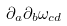Convert formula to latex. <formula><loc_0><loc_0><loc_500><loc_500>\partial _ { a } \partial _ { b } \omega _ { c d }</formula> 